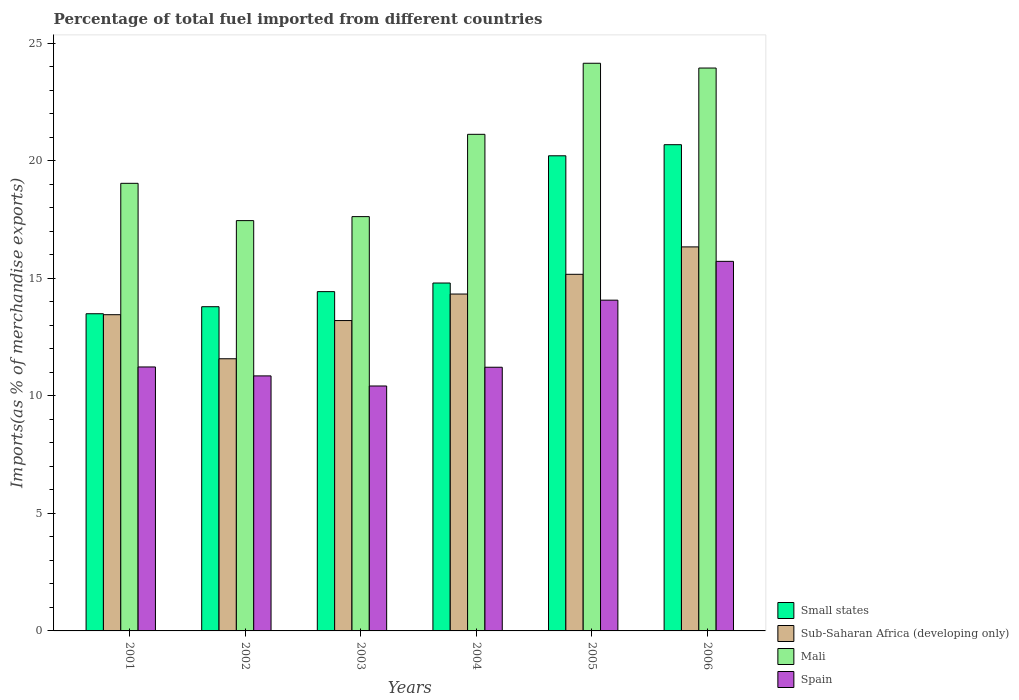How many different coloured bars are there?
Give a very brief answer. 4. How many groups of bars are there?
Keep it short and to the point. 6. Are the number of bars on each tick of the X-axis equal?
Your answer should be compact. Yes. How many bars are there on the 6th tick from the right?
Offer a terse response. 4. What is the label of the 2nd group of bars from the left?
Give a very brief answer. 2002. What is the percentage of imports to different countries in Sub-Saharan Africa (developing only) in 2006?
Your answer should be compact. 16.34. Across all years, what is the maximum percentage of imports to different countries in Mali?
Your response must be concise. 24.16. Across all years, what is the minimum percentage of imports to different countries in Sub-Saharan Africa (developing only)?
Make the answer very short. 11.58. In which year was the percentage of imports to different countries in Spain minimum?
Offer a terse response. 2003. What is the total percentage of imports to different countries in Spain in the graph?
Your response must be concise. 73.53. What is the difference between the percentage of imports to different countries in Mali in 2001 and that in 2004?
Offer a very short reply. -2.09. What is the difference between the percentage of imports to different countries in Sub-Saharan Africa (developing only) in 2003 and the percentage of imports to different countries in Mali in 2002?
Make the answer very short. -4.25. What is the average percentage of imports to different countries in Mali per year?
Provide a succinct answer. 20.56. In the year 2003, what is the difference between the percentage of imports to different countries in Mali and percentage of imports to different countries in Small states?
Make the answer very short. 3.19. What is the ratio of the percentage of imports to different countries in Spain in 2002 to that in 2004?
Make the answer very short. 0.97. Is the difference between the percentage of imports to different countries in Mali in 2002 and 2005 greater than the difference between the percentage of imports to different countries in Small states in 2002 and 2005?
Your response must be concise. No. What is the difference between the highest and the second highest percentage of imports to different countries in Mali?
Offer a very short reply. 0.2. What is the difference between the highest and the lowest percentage of imports to different countries in Spain?
Your response must be concise. 5.3. Is the sum of the percentage of imports to different countries in Sub-Saharan Africa (developing only) in 2001 and 2004 greater than the maximum percentage of imports to different countries in Mali across all years?
Provide a succinct answer. Yes. Is it the case that in every year, the sum of the percentage of imports to different countries in Spain and percentage of imports to different countries in Sub-Saharan Africa (developing only) is greater than the sum of percentage of imports to different countries in Small states and percentage of imports to different countries in Mali?
Keep it short and to the point. No. What does the 3rd bar from the left in 2002 represents?
Offer a terse response. Mali. Is it the case that in every year, the sum of the percentage of imports to different countries in Mali and percentage of imports to different countries in Small states is greater than the percentage of imports to different countries in Sub-Saharan Africa (developing only)?
Provide a succinct answer. Yes. Are all the bars in the graph horizontal?
Keep it short and to the point. No. How many years are there in the graph?
Give a very brief answer. 6. What is the difference between two consecutive major ticks on the Y-axis?
Provide a succinct answer. 5. Are the values on the major ticks of Y-axis written in scientific E-notation?
Provide a succinct answer. No. Does the graph contain any zero values?
Your response must be concise. No. How many legend labels are there?
Your answer should be very brief. 4. How are the legend labels stacked?
Your answer should be compact. Vertical. What is the title of the graph?
Make the answer very short. Percentage of total fuel imported from different countries. Does "Swaziland" appear as one of the legend labels in the graph?
Ensure brevity in your answer.  No. What is the label or title of the Y-axis?
Offer a terse response. Imports(as % of merchandise exports). What is the Imports(as % of merchandise exports) of Small states in 2001?
Keep it short and to the point. 13.5. What is the Imports(as % of merchandise exports) in Sub-Saharan Africa (developing only) in 2001?
Provide a short and direct response. 13.46. What is the Imports(as % of merchandise exports) in Mali in 2001?
Your response must be concise. 19.05. What is the Imports(as % of merchandise exports) of Spain in 2001?
Provide a short and direct response. 11.23. What is the Imports(as % of merchandise exports) of Small states in 2002?
Your answer should be very brief. 13.8. What is the Imports(as % of merchandise exports) of Sub-Saharan Africa (developing only) in 2002?
Keep it short and to the point. 11.58. What is the Imports(as % of merchandise exports) of Mali in 2002?
Offer a terse response. 17.46. What is the Imports(as % of merchandise exports) of Spain in 2002?
Ensure brevity in your answer.  10.85. What is the Imports(as % of merchandise exports) of Small states in 2003?
Your answer should be very brief. 14.44. What is the Imports(as % of merchandise exports) in Sub-Saharan Africa (developing only) in 2003?
Offer a terse response. 13.21. What is the Imports(as % of merchandise exports) in Mali in 2003?
Your response must be concise. 17.63. What is the Imports(as % of merchandise exports) of Spain in 2003?
Your answer should be very brief. 10.42. What is the Imports(as % of merchandise exports) of Small states in 2004?
Make the answer very short. 14.8. What is the Imports(as % of merchandise exports) in Sub-Saharan Africa (developing only) in 2004?
Offer a very short reply. 14.34. What is the Imports(as % of merchandise exports) in Mali in 2004?
Provide a short and direct response. 21.13. What is the Imports(as % of merchandise exports) in Spain in 2004?
Your answer should be compact. 11.22. What is the Imports(as % of merchandise exports) in Small states in 2005?
Offer a terse response. 20.22. What is the Imports(as % of merchandise exports) of Sub-Saharan Africa (developing only) in 2005?
Give a very brief answer. 15.17. What is the Imports(as % of merchandise exports) in Mali in 2005?
Make the answer very short. 24.16. What is the Imports(as % of merchandise exports) of Spain in 2005?
Offer a terse response. 14.07. What is the Imports(as % of merchandise exports) of Small states in 2006?
Your answer should be very brief. 20.69. What is the Imports(as % of merchandise exports) in Sub-Saharan Africa (developing only) in 2006?
Ensure brevity in your answer.  16.34. What is the Imports(as % of merchandise exports) in Mali in 2006?
Give a very brief answer. 23.95. What is the Imports(as % of merchandise exports) in Spain in 2006?
Provide a short and direct response. 15.73. Across all years, what is the maximum Imports(as % of merchandise exports) of Small states?
Ensure brevity in your answer.  20.69. Across all years, what is the maximum Imports(as % of merchandise exports) in Sub-Saharan Africa (developing only)?
Ensure brevity in your answer.  16.34. Across all years, what is the maximum Imports(as % of merchandise exports) of Mali?
Offer a very short reply. 24.16. Across all years, what is the maximum Imports(as % of merchandise exports) in Spain?
Your answer should be compact. 15.73. Across all years, what is the minimum Imports(as % of merchandise exports) of Small states?
Give a very brief answer. 13.5. Across all years, what is the minimum Imports(as % of merchandise exports) of Sub-Saharan Africa (developing only)?
Your response must be concise. 11.58. Across all years, what is the minimum Imports(as % of merchandise exports) in Mali?
Keep it short and to the point. 17.46. Across all years, what is the minimum Imports(as % of merchandise exports) of Spain?
Give a very brief answer. 10.42. What is the total Imports(as % of merchandise exports) in Small states in the graph?
Your response must be concise. 97.44. What is the total Imports(as % of merchandise exports) of Sub-Saharan Africa (developing only) in the graph?
Keep it short and to the point. 84.1. What is the total Imports(as % of merchandise exports) of Mali in the graph?
Keep it short and to the point. 123.38. What is the total Imports(as % of merchandise exports) of Spain in the graph?
Make the answer very short. 73.53. What is the difference between the Imports(as % of merchandise exports) of Small states in 2001 and that in 2002?
Provide a short and direct response. -0.3. What is the difference between the Imports(as % of merchandise exports) in Sub-Saharan Africa (developing only) in 2001 and that in 2002?
Offer a terse response. 1.88. What is the difference between the Imports(as % of merchandise exports) of Mali in 2001 and that in 2002?
Give a very brief answer. 1.59. What is the difference between the Imports(as % of merchandise exports) in Spain in 2001 and that in 2002?
Ensure brevity in your answer.  0.38. What is the difference between the Imports(as % of merchandise exports) in Small states in 2001 and that in 2003?
Offer a very short reply. -0.94. What is the difference between the Imports(as % of merchandise exports) of Sub-Saharan Africa (developing only) in 2001 and that in 2003?
Your answer should be compact. 0.25. What is the difference between the Imports(as % of merchandise exports) in Mali in 2001 and that in 2003?
Make the answer very short. 1.42. What is the difference between the Imports(as % of merchandise exports) in Spain in 2001 and that in 2003?
Provide a short and direct response. 0.81. What is the difference between the Imports(as % of merchandise exports) of Small states in 2001 and that in 2004?
Offer a terse response. -1.31. What is the difference between the Imports(as % of merchandise exports) in Sub-Saharan Africa (developing only) in 2001 and that in 2004?
Offer a terse response. -0.88. What is the difference between the Imports(as % of merchandise exports) of Mali in 2001 and that in 2004?
Offer a very short reply. -2.09. What is the difference between the Imports(as % of merchandise exports) in Spain in 2001 and that in 2004?
Keep it short and to the point. 0.01. What is the difference between the Imports(as % of merchandise exports) of Small states in 2001 and that in 2005?
Make the answer very short. -6.72. What is the difference between the Imports(as % of merchandise exports) in Sub-Saharan Africa (developing only) in 2001 and that in 2005?
Your answer should be compact. -1.72. What is the difference between the Imports(as % of merchandise exports) in Mali in 2001 and that in 2005?
Provide a succinct answer. -5.11. What is the difference between the Imports(as % of merchandise exports) of Spain in 2001 and that in 2005?
Provide a succinct answer. -2.84. What is the difference between the Imports(as % of merchandise exports) of Small states in 2001 and that in 2006?
Your answer should be compact. -7.19. What is the difference between the Imports(as % of merchandise exports) of Sub-Saharan Africa (developing only) in 2001 and that in 2006?
Make the answer very short. -2.89. What is the difference between the Imports(as % of merchandise exports) in Mali in 2001 and that in 2006?
Your response must be concise. -4.91. What is the difference between the Imports(as % of merchandise exports) of Spain in 2001 and that in 2006?
Your response must be concise. -4.49. What is the difference between the Imports(as % of merchandise exports) in Small states in 2002 and that in 2003?
Provide a short and direct response. -0.64. What is the difference between the Imports(as % of merchandise exports) in Sub-Saharan Africa (developing only) in 2002 and that in 2003?
Provide a succinct answer. -1.63. What is the difference between the Imports(as % of merchandise exports) in Mali in 2002 and that in 2003?
Provide a succinct answer. -0.17. What is the difference between the Imports(as % of merchandise exports) of Spain in 2002 and that in 2003?
Give a very brief answer. 0.43. What is the difference between the Imports(as % of merchandise exports) in Small states in 2002 and that in 2004?
Your answer should be very brief. -1.01. What is the difference between the Imports(as % of merchandise exports) of Sub-Saharan Africa (developing only) in 2002 and that in 2004?
Provide a short and direct response. -2.75. What is the difference between the Imports(as % of merchandise exports) in Mali in 2002 and that in 2004?
Provide a short and direct response. -3.67. What is the difference between the Imports(as % of merchandise exports) of Spain in 2002 and that in 2004?
Make the answer very short. -0.37. What is the difference between the Imports(as % of merchandise exports) in Small states in 2002 and that in 2005?
Your answer should be compact. -6.42. What is the difference between the Imports(as % of merchandise exports) in Sub-Saharan Africa (developing only) in 2002 and that in 2005?
Give a very brief answer. -3.59. What is the difference between the Imports(as % of merchandise exports) of Mali in 2002 and that in 2005?
Make the answer very short. -6.7. What is the difference between the Imports(as % of merchandise exports) in Spain in 2002 and that in 2005?
Your response must be concise. -3.22. What is the difference between the Imports(as % of merchandise exports) of Small states in 2002 and that in 2006?
Your answer should be very brief. -6.89. What is the difference between the Imports(as % of merchandise exports) of Sub-Saharan Africa (developing only) in 2002 and that in 2006?
Offer a very short reply. -4.76. What is the difference between the Imports(as % of merchandise exports) of Mali in 2002 and that in 2006?
Your response must be concise. -6.49. What is the difference between the Imports(as % of merchandise exports) of Spain in 2002 and that in 2006?
Offer a very short reply. -4.87. What is the difference between the Imports(as % of merchandise exports) in Small states in 2003 and that in 2004?
Your answer should be very brief. -0.37. What is the difference between the Imports(as % of merchandise exports) of Sub-Saharan Africa (developing only) in 2003 and that in 2004?
Provide a succinct answer. -1.13. What is the difference between the Imports(as % of merchandise exports) in Mali in 2003 and that in 2004?
Offer a very short reply. -3.5. What is the difference between the Imports(as % of merchandise exports) in Spain in 2003 and that in 2004?
Give a very brief answer. -0.8. What is the difference between the Imports(as % of merchandise exports) of Small states in 2003 and that in 2005?
Offer a terse response. -5.78. What is the difference between the Imports(as % of merchandise exports) in Sub-Saharan Africa (developing only) in 2003 and that in 2005?
Provide a short and direct response. -1.97. What is the difference between the Imports(as % of merchandise exports) in Mali in 2003 and that in 2005?
Provide a succinct answer. -6.53. What is the difference between the Imports(as % of merchandise exports) in Spain in 2003 and that in 2005?
Offer a very short reply. -3.65. What is the difference between the Imports(as % of merchandise exports) of Small states in 2003 and that in 2006?
Your response must be concise. -6.25. What is the difference between the Imports(as % of merchandise exports) in Sub-Saharan Africa (developing only) in 2003 and that in 2006?
Keep it short and to the point. -3.13. What is the difference between the Imports(as % of merchandise exports) of Mali in 2003 and that in 2006?
Your response must be concise. -6.32. What is the difference between the Imports(as % of merchandise exports) in Spain in 2003 and that in 2006?
Your answer should be compact. -5.3. What is the difference between the Imports(as % of merchandise exports) in Small states in 2004 and that in 2005?
Offer a very short reply. -5.41. What is the difference between the Imports(as % of merchandise exports) in Sub-Saharan Africa (developing only) in 2004 and that in 2005?
Provide a short and direct response. -0.84. What is the difference between the Imports(as % of merchandise exports) of Mali in 2004 and that in 2005?
Ensure brevity in your answer.  -3.02. What is the difference between the Imports(as % of merchandise exports) in Spain in 2004 and that in 2005?
Provide a short and direct response. -2.85. What is the difference between the Imports(as % of merchandise exports) of Small states in 2004 and that in 2006?
Give a very brief answer. -5.89. What is the difference between the Imports(as % of merchandise exports) of Sub-Saharan Africa (developing only) in 2004 and that in 2006?
Provide a succinct answer. -2.01. What is the difference between the Imports(as % of merchandise exports) in Mali in 2004 and that in 2006?
Provide a short and direct response. -2.82. What is the difference between the Imports(as % of merchandise exports) of Spain in 2004 and that in 2006?
Ensure brevity in your answer.  -4.51. What is the difference between the Imports(as % of merchandise exports) of Small states in 2005 and that in 2006?
Your response must be concise. -0.47. What is the difference between the Imports(as % of merchandise exports) of Sub-Saharan Africa (developing only) in 2005 and that in 2006?
Your answer should be very brief. -1.17. What is the difference between the Imports(as % of merchandise exports) of Mali in 2005 and that in 2006?
Your answer should be compact. 0.2. What is the difference between the Imports(as % of merchandise exports) of Spain in 2005 and that in 2006?
Keep it short and to the point. -1.65. What is the difference between the Imports(as % of merchandise exports) in Small states in 2001 and the Imports(as % of merchandise exports) in Sub-Saharan Africa (developing only) in 2002?
Your response must be concise. 1.92. What is the difference between the Imports(as % of merchandise exports) in Small states in 2001 and the Imports(as % of merchandise exports) in Mali in 2002?
Ensure brevity in your answer.  -3.96. What is the difference between the Imports(as % of merchandise exports) of Small states in 2001 and the Imports(as % of merchandise exports) of Spain in 2002?
Your answer should be compact. 2.64. What is the difference between the Imports(as % of merchandise exports) of Sub-Saharan Africa (developing only) in 2001 and the Imports(as % of merchandise exports) of Mali in 2002?
Ensure brevity in your answer.  -4. What is the difference between the Imports(as % of merchandise exports) in Sub-Saharan Africa (developing only) in 2001 and the Imports(as % of merchandise exports) in Spain in 2002?
Make the answer very short. 2.6. What is the difference between the Imports(as % of merchandise exports) in Mali in 2001 and the Imports(as % of merchandise exports) in Spain in 2002?
Keep it short and to the point. 8.19. What is the difference between the Imports(as % of merchandise exports) in Small states in 2001 and the Imports(as % of merchandise exports) in Sub-Saharan Africa (developing only) in 2003?
Provide a succinct answer. 0.29. What is the difference between the Imports(as % of merchandise exports) of Small states in 2001 and the Imports(as % of merchandise exports) of Mali in 2003?
Provide a succinct answer. -4.13. What is the difference between the Imports(as % of merchandise exports) in Small states in 2001 and the Imports(as % of merchandise exports) in Spain in 2003?
Offer a terse response. 3.07. What is the difference between the Imports(as % of merchandise exports) of Sub-Saharan Africa (developing only) in 2001 and the Imports(as % of merchandise exports) of Mali in 2003?
Ensure brevity in your answer.  -4.17. What is the difference between the Imports(as % of merchandise exports) of Sub-Saharan Africa (developing only) in 2001 and the Imports(as % of merchandise exports) of Spain in 2003?
Give a very brief answer. 3.03. What is the difference between the Imports(as % of merchandise exports) in Mali in 2001 and the Imports(as % of merchandise exports) in Spain in 2003?
Offer a terse response. 8.62. What is the difference between the Imports(as % of merchandise exports) in Small states in 2001 and the Imports(as % of merchandise exports) in Sub-Saharan Africa (developing only) in 2004?
Give a very brief answer. -0.84. What is the difference between the Imports(as % of merchandise exports) of Small states in 2001 and the Imports(as % of merchandise exports) of Mali in 2004?
Your answer should be very brief. -7.64. What is the difference between the Imports(as % of merchandise exports) in Small states in 2001 and the Imports(as % of merchandise exports) in Spain in 2004?
Keep it short and to the point. 2.28. What is the difference between the Imports(as % of merchandise exports) of Sub-Saharan Africa (developing only) in 2001 and the Imports(as % of merchandise exports) of Mali in 2004?
Give a very brief answer. -7.68. What is the difference between the Imports(as % of merchandise exports) of Sub-Saharan Africa (developing only) in 2001 and the Imports(as % of merchandise exports) of Spain in 2004?
Your answer should be compact. 2.24. What is the difference between the Imports(as % of merchandise exports) in Mali in 2001 and the Imports(as % of merchandise exports) in Spain in 2004?
Your answer should be compact. 7.83. What is the difference between the Imports(as % of merchandise exports) of Small states in 2001 and the Imports(as % of merchandise exports) of Sub-Saharan Africa (developing only) in 2005?
Provide a short and direct response. -1.68. What is the difference between the Imports(as % of merchandise exports) of Small states in 2001 and the Imports(as % of merchandise exports) of Mali in 2005?
Make the answer very short. -10.66. What is the difference between the Imports(as % of merchandise exports) in Small states in 2001 and the Imports(as % of merchandise exports) in Spain in 2005?
Offer a very short reply. -0.58. What is the difference between the Imports(as % of merchandise exports) of Sub-Saharan Africa (developing only) in 2001 and the Imports(as % of merchandise exports) of Mali in 2005?
Give a very brief answer. -10.7. What is the difference between the Imports(as % of merchandise exports) in Sub-Saharan Africa (developing only) in 2001 and the Imports(as % of merchandise exports) in Spain in 2005?
Your answer should be very brief. -0.62. What is the difference between the Imports(as % of merchandise exports) of Mali in 2001 and the Imports(as % of merchandise exports) of Spain in 2005?
Your response must be concise. 4.97. What is the difference between the Imports(as % of merchandise exports) of Small states in 2001 and the Imports(as % of merchandise exports) of Sub-Saharan Africa (developing only) in 2006?
Your answer should be very brief. -2.84. What is the difference between the Imports(as % of merchandise exports) of Small states in 2001 and the Imports(as % of merchandise exports) of Mali in 2006?
Give a very brief answer. -10.46. What is the difference between the Imports(as % of merchandise exports) in Small states in 2001 and the Imports(as % of merchandise exports) in Spain in 2006?
Keep it short and to the point. -2.23. What is the difference between the Imports(as % of merchandise exports) in Sub-Saharan Africa (developing only) in 2001 and the Imports(as % of merchandise exports) in Mali in 2006?
Make the answer very short. -10.5. What is the difference between the Imports(as % of merchandise exports) of Sub-Saharan Africa (developing only) in 2001 and the Imports(as % of merchandise exports) of Spain in 2006?
Make the answer very short. -2.27. What is the difference between the Imports(as % of merchandise exports) in Mali in 2001 and the Imports(as % of merchandise exports) in Spain in 2006?
Your answer should be compact. 3.32. What is the difference between the Imports(as % of merchandise exports) in Small states in 2002 and the Imports(as % of merchandise exports) in Sub-Saharan Africa (developing only) in 2003?
Give a very brief answer. 0.59. What is the difference between the Imports(as % of merchandise exports) in Small states in 2002 and the Imports(as % of merchandise exports) in Mali in 2003?
Provide a succinct answer. -3.83. What is the difference between the Imports(as % of merchandise exports) in Small states in 2002 and the Imports(as % of merchandise exports) in Spain in 2003?
Give a very brief answer. 3.37. What is the difference between the Imports(as % of merchandise exports) in Sub-Saharan Africa (developing only) in 2002 and the Imports(as % of merchandise exports) in Mali in 2003?
Your answer should be very brief. -6.05. What is the difference between the Imports(as % of merchandise exports) in Sub-Saharan Africa (developing only) in 2002 and the Imports(as % of merchandise exports) in Spain in 2003?
Your answer should be compact. 1.16. What is the difference between the Imports(as % of merchandise exports) of Mali in 2002 and the Imports(as % of merchandise exports) of Spain in 2003?
Keep it short and to the point. 7.04. What is the difference between the Imports(as % of merchandise exports) of Small states in 2002 and the Imports(as % of merchandise exports) of Sub-Saharan Africa (developing only) in 2004?
Your response must be concise. -0.54. What is the difference between the Imports(as % of merchandise exports) of Small states in 2002 and the Imports(as % of merchandise exports) of Mali in 2004?
Provide a succinct answer. -7.34. What is the difference between the Imports(as % of merchandise exports) in Small states in 2002 and the Imports(as % of merchandise exports) in Spain in 2004?
Your response must be concise. 2.58. What is the difference between the Imports(as % of merchandise exports) of Sub-Saharan Africa (developing only) in 2002 and the Imports(as % of merchandise exports) of Mali in 2004?
Offer a very short reply. -9.55. What is the difference between the Imports(as % of merchandise exports) in Sub-Saharan Africa (developing only) in 2002 and the Imports(as % of merchandise exports) in Spain in 2004?
Keep it short and to the point. 0.36. What is the difference between the Imports(as % of merchandise exports) in Mali in 2002 and the Imports(as % of merchandise exports) in Spain in 2004?
Your response must be concise. 6.24. What is the difference between the Imports(as % of merchandise exports) of Small states in 2002 and the Imports(as % of merchandise exports) of Sub-Saharan Africa (developing only) in 2005?
Your answer should be compact. -1.38. What is the difference between the Imports(as % of merchandise exports) in Small states in 2002 and the Imports(as % of merchandise exports) in Mali in 2005?
Keep it short and to the point. -10.36. What is the difference between the Imports(as % of merchandise exports) in Small states in 2002 and the Imports(as % of merchandise exports) in Spain in 2005?
Offer a terse response. -0.28. What is the difference between the Imports(as % of merchandise exports) in Sub-Saharan Africa (developing only) in 2002 and the Imports(as % of merchandise exports) in Mali in 2005?
Make the answer very short. -12.57. What is the difference between the Imports(as % of merchandise exports) of Sub-Saharan Africa (developing only) in 2002 and the Imports(as % of merchandise exports) of Spain in 2005?
Your answer should be very brief. -2.49. What is the difference between the Imports(as % of merchandise exports) in Mali in 2002 and the Imports(as % of merchandise exports) in Spain in 2005?
Keep it short and to the point. 3.39. What is the difference between the Imports(as % of merchandise exports) in Small states in 2002 and the Imports(as % of merchandise exports) in Sub-Saharan Africa (developing only) in 2006?
Offer a terse response. -2.55. What is the difference between the Imports(as % of merchandise exports) in Small states in 2002 and the Imports(as % of merchandise exports) in Mali in 2006?
Offer a very short reply. -10.16. What is the difference between the Imports(as % of merchandise exports) in Small states in 2002 and the Imports(as % of merchandise exports) in Spain in 2006?
Provide a short and direct response. -1.93. What is the difference between the Imports(as % of merchandise exports) in Sub-Saharan Africa (developing only) in 2002 and the Imports(as % of merchandise exports) in Mali in 2006?
Keep it short and to the point. -12.37. What is the difference between the Imports(as % of merchandise exports) in Sub-Saharan Africa (developing only) in 2002 and the Imports(as % of merchandise exports) in Spain in 2006?
Offer a very short reply. -4.14. What is the difference between the Imports(as % of merchandise exports) in Mali in 2002 and the Imports(as % of merchandise exports) in Spain in 2006?
Give a very brief answer. 1.73. What is the difference between the Imports(as % of merchandise exports) in Small states in 2003 and the Imports(as % of merchandise exports) in Sub-Saharan Africa (developing only) in 2004?
Offer a very short reply. 0.1. What is the difference between the Imports(as % of merchandise exports) in Small states in 2003 and the Imports(as % of merchandise exports) in Mali in 2004?
Keep it short and to the point. -6.69. What is the difference between the Imports(as % of merchandise exports) of Small states in 2003 and the Imports(as % of merchandise exports) of Spain in 2004?
Your answer should be very brief. 3.22. What is the difference between the Imports(as % of merchandise exports) in Sub-Saharan Africa (developing only) in 2003 and the Imports(as % of merchandise exports) in Mali in 2004?
Offer a very short reply. -7.92. What is the difference between the Imports(as % of merchandise exports) of Sub-Saharan Africa (developing only) in 2003 and the Imports(as % of merchandise exports) of Spain in 2004?
Your answer should be very brief. 1.99. What is the difference between the Imports(as % of merchandise exports) of Mali in 2003 and the Imports(as % of merchandise exports) of Spain in 2004?
Offer a very short reply. 6.41. What is the difference between the Imports(as % of merchandise exports) of Small states in 2003 and the Imports(as % of merchandise exports) of Sub-Saharan Africa (developing only) in 2005?
Provide a succinct answer. -0.74. What is the difference between the Imports(as % of merchandise exports) in Small states in 2003 and the Imports(as % of merchandise exports) in Mali in 2005?
Your answer should be very brief. -9.72. What is the difference between the Imports(as % of merchandise exports) of Small states in 2003 and the Imports(as % of merchandise exports) of Spain in 2005?
Offer a very short reply. 0.36. What is the difference between the Imports(as % of merchandise exports) in Sub-Saharan Africa (developing only) in 2003 and the Imports(as % of merchandise exports) in Mali in 2005?
Provide a succinct answer. -10.95. What is the difference between the Imports(as % of merchandise exports) in Sub-Saharan Africa (developing only) in 2003 and the Imports(as % of merchandise exports) in Spain in 2005?
Provide a short and direct response. -0.87. What is the difference between the Imports(as % of merchandise exports) in Mali in 2003 and the Imports(as % of merchandise exports) in Spain in 2005?
Your answer should be very brief. 3.56. What is the difference between the Imports(as % of merchandise exports) in Small states in 2003 and the Imports(as % of merchandise exports) in Sub-Saharan Africa (developing only) in 2006?
Your response must be concise. -1.9. What is the difference between the Imports(as % of merchandise exports) in Small states in 2003 and the Imports(as % of merchandise exports) in Mali in 2006?
Offer a terse response. -9.52. What is the difference between the Imports(as % of merchandise exports) in Small states in 2003 and the Imports(as % of merchandise exports) in Spain in 2006?
Your answer should be compact. -1.29. What is the difference between the Imports(as % of merchandise exports) in Sub-Saharan Africa (developing only) in 2003 and the Imports(as % of merchandise exports) in Mali in 2006?
Your answer should be very brief. -10.75. What is the difference between the Imports(as % of merchandise exports) in Sub-Saharan Africa (developing only) in 2003 and the Imports(as % of merchandise exports) in Spain in 2006?
Provide a short and direct response. -2.52. What is the difference between the Imports(as % of merchandise exports) in Mali in 2003 and the Imports(as % of merchandise exports) in Spain in 2006?
Provide a succinct answer. 1.9. What is the difference between the Imports(as % of merchandise exports) of Small states in 2004 and the Imports(as % of merchandise exports) of Sub-Saharan Africa (developing only) in 2005?
Provide a short and direct response. -0.37. What is the difference between the Imports(as % of merchandise exports) of Small states in 2004 and the Imports(as % of merchandise exports) of Mali in 2005?
Give a very brief answer. -9.35. What is the difference between the Imports(as % of merchandise exports) in Small states in 2004 and the Imports(as % of merchandise exports) in Spain in 2005?
Your response must be concise. 0.73. What is the difference between the Imports(as % of merchandise exports) in Sub-Saharan Africa (developing only) in 2004 and the Imports(as % of merchandise exports) in Mali in 2005?
Provide a short and direct response. -9.82. What is the difference between the Imports(as % of merchandise exports) in Sub-Saharan Africa (developing only) in 2004 and the Imports(as % of merchandise exports) in Spain in 2005?
Give a very brief answer. 0.26. What is the difference between the Imports(as % of merchandise exports) in Mali in 2004 and the Imports(as % of merchandise exports) in Spain in 2005?
Keep it short and to the point. 7.06. What is the difference between the Imports(as % of merchandise exports) of Small states in 2004 and the Imports(as % of merchandise exports) of Sub-Saharan Africa (developing only) in 2006?
Your answer should be compact. -1.54. What is the difference between the Imports(as % of merchandise exports) in Small states in 2004 and the Imports(as % of merchandise exports) in Mali in 2006?
Give a very brief answer. -9.15. What is the difference between the Imports(as % of merchandise exports) in Small states in 2004 and the Imports(as % of merchandise exports) in Spain in 2006?
Your response must be concise. -0.92. What is the difference between the Imports(as % of merchandise exports) of Sub-Saharan Africa (developing only) in 2004 and the Imports(as % of merchandise exports) of Mali in 2006?
Keep it short and to the point. -9.62. What is the difference between the Imports(as % of merchandise exports) in Sub-Saharan Africa (developing only) in 2004 and the Imports(as % of merchandise exports) in Spain in 2006?
Give a very brief answer. -1.39. What is the difference between the Imports(as % of merchandise exports) in Mali in 2004 and the Imports(as % of merchandise exports) in Spain in 2006?
Keep it short and to the point. 5.41. What is the difference between the Imports(as % of merchandise exports) in Small states in 2005 and the Imports(as % of merchandise exports) in Sub-Saharan Africa (developing only) in 2006?
Your answer should be very brief. 3.88. What is the difference between the Imports(as % of merchandise exports) in Small states in 2005 and the Imports(as % of merchandise exports) in Mali in 2006?
Offer a very short reply. -3.73. What is the difference between the Imports(as % of merchandise exports) in Small states in 2005 and the Imports(as % of merchandise exports) in Spain in 2006?
Keep it short and to the point. 4.49. What is the difference between the Imports(as % of merchandise exports) of Sub-Saharan Africa (developing only) in 2005 and the Imports(as % of merchandise exports) of Mali in 2006?
Offer a very short reply. -8.78. What is the difference between the Imports(as % of merchandise exports) in Sub-Saharan Africa (developing only) in 2005 and the Imports(as % of merchandise exports) in Spain in 2006?
Make the answer very short. -0.55. What is the difference between the Imports(as % of merchandise exports) in Mali in 2005 and the Imports(as % of merchandise exports) in Spain in 2006?
Ensure brevity in your answer.  8.43. What is the average Imports(as % of merchandise exports) in Small states per year?
Offer a terse response. 16.24. What is the average Imports(as % of merchandise exports) in Sub-Saharan Africa (developing only) per year?
Keep it short and to the point. 14.02. What is the average Imports(as % of merchandise exports) of Mali per year?
Give a very brief answer. 20.56. What is the average Imports(as % of merchandise exports) in Spain per year?
Offer a very short reply. 12.25. In the year 2001, what is the difference between the Imports(as % of merchandise exports) of Small states and Imports(as % of merchandise exports) of Sub-Saharan Africa (developing only)?
Provide a succinct answer. 0.04. In the year 2001, what is the difference between the Imports(as % of merchandise exports) in Small states and Imports(as % of merchandise exports) in Mali?
Keep it short and to the point. -5.55. In the year 2001, what is the difference between the Imports(as % of merchandise exports) in Small states and Imports(as % of merchandise exports) in Spain?
Provide a short and direct response. 2.26. In the year 2001, what is the difference between the Imports(as % of merchandise exports) in Sub-Saharan Africa (developing only) and Imports(as % of merchandise exports) in Mali?
Your answer should be very brief. -5.59. In the year 2001, what is the difference between the Imports(as % of merchandise exports) of Sub-Saharan Africa (developing only) and Imports(as % of merchandise exports) of Spain?
Give a very brief answer. 2.22. In the year 2001, what is the difference between the Imports(as % of merchandise exports) in Mali and Imports(as % of merchandise exports) in Spain?
Your answer should be compact. 7.81. In the year 2002, what is the difference between the Imports(as % of merchandise exports) of Small states and Imports(as % of merchandise exports) of Sub-Saharan Africa (developing only)?
Offer a very short reply. 2.21. In the year 2002, what is the difference between the Imports(as % of merchandise exports) of Small states and Imports(as % of merchandise exports) of Mali?
Ensure brevity in your answer.  -3.66. In the year 2002, what is the difference between the Imports(as % of merchandise exports) in Small states and Imports(as % of merchandise exports) in Spain?
Your answer should be compact. 2.94. In the year 2002, what is the difference between the Imports(as % of merchandise exports) in Sub-Saharan Africa (developing only) and Imports(as % of merchandise exports) in Mali?
Your answer should be very brief. -5.88. In the year 2002, what is the difference between the Imports(as % of merchandise exports) in Sub-Saharan Africa (developing only) and Imports(as % of merchandise exports) in Spain?
Keep it short and to the point. 0.73. In the year 2002, what is the difference between the Imports(as % of merchandise exports) in Mali and Imports(as % of merchandise exports) in Spain?
Your answer should be compact. 6.61. In the year 2003, what is the difference between the Imports(as % of merchandise exports) of Small states and Imports(as % of merchandise exports) of Sub-Saharan Africa (developing only)?
Provide a short and direct response. 1.23. In the year 2003, what is the difference between the Imports(as % of merchandise exports) in Small states and Imports(as % of merchandise exports) in Mali?
Provide a succinct answer. -3.19. In the year 2003, what is the difference between the Imports(as % of merchandise exports) of Small states and Imports(as % of merchandise exports) of Spain?
Offer a very short reply. 4.01. In the year 2003, what is the difference between the Imports(as % of merchandise exports) in Sub-Saharan Africa (developing only) and Imports(as % of merchandise exports) in Mali?
Your answer should be compact. -4.42. In the year 2003, what is the difference between the Imports(as % of merchandise exports) of Sub-Saharan Africa (developing only) and Imports(as % of merchandise exports) of Spain?
Offer a very short reply. 2.78. In the year 2003, what is the difference between the Imports(as % of merchandise exports) in Mali and Imports(as % of merchandise exports) in Spain?
Make the answer very short. 7.21. In the year 2004, what is the difference between the Imports(as % of merchandise exports) in Small states and Imports(as % of merchandise exports) in Sub-Saharan Africa (developing only)?
Provide a succinct answer. 0.47. In the year 2004, what is the difference between the Imports(as % of merchandise exports) of Small states and Imports(as % of merchandise exports) of Mali?
Your answer should be compact. -6.33. In the year 2004, what is the difference between the Imports(as % of merchandise exports) in Small states and Imports(as % of merchandise exports) in Spain?
Keep it short and to the point. 3.58. In the year 2004, what is the difference between the Imports(as % of merchandise exports) in Sub-Saharan Africa (developing only) and Imports(as % of merchandise exports) in Mali?
Your answer should be very brief. -6.8. In the year 2004, what is the difference between the Imports(as % of merchandise exports) in Sub-Saharan Africa (developing only) and Imports(as % of merchandise exports) in Spain?
Ensure brevity in your answer.  3.12. In the year 2004, what is the difference between the Imports(as % of merchandise exports) in Mali and Imports(as % of merchandise exports) in Spain?
Provide a short and direct response. 9.91. In the year 2005, what is the difference between the Imports(as % of merchandise exports) of Small states and Imports(as % of merchandise exports) of Sub-Saharan Africa (developing only)?
Your response must be concise. 5.04. In the year 2005, what is the difference between the Imports(as % of merchandise exports) of Small states and Imports(as % of merchandise exports) of Mali?
Provide a short and direct response. -3.94. In the year 2005, what is the difference between the Imports(as % of merchandise exports) of Small states and Imports(as % of merchandise exports) of Spain?
Your answer should be compact. 6.14. In the year 2005, what is the difference between the Imports(as % of merchandise exports) in Sub-Saharan Africa (developing only) and Imports(as % of merchandise exports) in Mali?
Provide a short and direct response. -8.98. In the year 2005, what is the difference between the Imports(as % of merchandise exports) of Sub-Saharan Africa (developing only) and Imports(as % of merchandise exports) of Spain?
Your answer should be compact. 1.1. In the year 2005, what is the difference between the Imports(as % of merchandise exports) in Mali and Imports(as % of merchandise exports) in Spain?
Offer a terse response. 10.08. In the year 2006, what is the difference between the Imports(as % of merchandise exports) of Small states and Imports(as % of merchandise exports) of Sub-Saharan Africa (developing only)?
Provide a succinct answer. 4.35. In the year 2006, what is the difference between the Imports(as % of merchandise exports) of Small states and Imports(as % of merchandise exports) of Mali?
Offer a terse response. -3.26. In the year 2006, what is the difference between the Imports(as % of merchandise exports) in Small states and Imports(as % of merchandise exports) in Spain?
Provide a succinct answer. 4.96. In the year 2006, what is the difference between the Imports(as % of merchandise exports) in Sub-Saharan Africa (developing only) and Imports(as % of merchandise exports) in Mali?
Offer a very short reply. -7.61. In the year 2006, what is the difference between the Imports(as % of merchandise exports) of Sub-Saharan Africa (developing only) and Imports(as % of merchandise exports) of Spain?
Ensure brevity in your answer.  0.62. In the year 2006, what is the difference between the Imports(as % of merchandise exports) of Mali and Imports(as % of merchandise exports) of Spain?
Give a very brief answer. 8.23. What is the ratio of the Imports(as % of merchandise exports) of Small states in 2001 to that in 2002?
Your answer should be very brief. 0.98. What is the ratio of the Imports(as % of merchandise exports) in Sub-Saharan Africa (developing only) in 2001 to that in 2002?
Provide a succinct answer. 1.16. What is the ratio of the Imports(as % of merchandise exports) in Spain in 2001 to that in 2002?
Your answer should be very brief. 1.04. What is the ratio of the Imports(as % of merchandise exports) in Small states in 2001 to that in 2003?
Offer a very short reply. 0.93. What is the ratio of the Imports(as % of merchandise exports) in Sub-Saharan Africa (developing only) in 2001 to that in 2003?
Provide a short and direct response. 1.02. What is the ratio of the Imports(as % of merchandise exports) of Mali in 2001 to that in 2003?
Give a very brief answer. 1.08. What is the ratio of the Imports(as % of merchandise exports) in Spain in 2001 to that in 2003?
Provide a short and direct response. 1.08. What is the ratio of the Imports(as % of merchandise exports) in Small states in 2001 to that in 2004?
Offer a terse response. 0.91. What is the ratio of the Imports(as % of merchandise exports) in Sub-Saharan Africa (developing only) in 2001 to that in 2004?
Ensure brevity in your answer.  0.94. What is the ratio of the Imports(as % of merchandise exports) of Mali in 2001 to that in 2004?
Give a very brief answer. 0.9. What is the ratio of the Imports(as % of merchandise exports) in Spain in 2001 to that in 2004?
Provide a succinct answer. 1. What is the ratio of the Imports(as % of merchandise exports) of Small states in 2001 to that in 2005?
Give a very brief answer. 0.67. What is the ratio of the Imports(as % of merchandise exports) of Sub-Saharan Africa (developing only) in 2001 to that in 2005?
Offer a very short reply. 0.89. What is the ratio of the Imports(as % of merchandise exports) of Mali in 2001 to that in 2005?
Make the answer very short. 0.79. What is the ratio of the Imports(as % of merchandise exports) in Spain in 2001 to that in 2005?
Your response must be concise. 0.8. What is the ratio of the Imports(as % of merchandise exports) of Small states in 2001 to that in 2006?
Give a very brief answer. 0.65. What is the ratio of the Imports(as % of merchandise exports) of Sub-Saharan Africa (developing only) in 2001 to that in 2006?
Offer a terse response. 0.82. What is the ratio of the Imports(as % of merchandise exports) of Mali in 2001 to that in 2006?
Provide a succinct answer. 0.8. What is the ratio of the Imports(as % of merchandise exports) of Small states in 2002 to that in 2003?
Provide a succinct answer. 0.96. What is the ratio of the Imports(as % of merchandise exports) in Sub-Saharan Africa (developing only) in 2002 to that in 2003?
Your answer should be compact. 0.88. What is the ratio of the Imports(as % of merchandise exports) in Mali in 2002 to that in 2003?
Offer a terse response. 0.99. What is the ratio of the Imports(as % of merchandise exports) in Spain in 2002 to that in 2003?
Provide a succinct answer. 1.04. What is the ratio of the Imports(as % of merchandise exports) of Small states in 2002 to that in 2004?
Your response must be concise. 0.93. What is the ratio of the Imports(as % of merchandise exports) in Sub-Saharan Africa (developing only) in 2002 to that in 2004?
Ensure brevity in your answer.  0.81. What is the ratio of the Imports(as % of merchandise exports) in Mali in 2002 to that in 2004?
Give a very brief answer. 0.83. What is the ratio of the Imports(as % of merchandise exports) of Spain in 2002 to that in 2004?
Offer a very short reply. 0.97. What is the ratio of the Imports(as % of merchandise exports) in Small states in 2002 to that in 2005?
Provide a short and direct response. 0.68. What is the ratio of the Imports(as % of merchandise exports) in Sub-Saharan Africa (developing only) in 2002 to that in 2005?
Your response must be concise. 0.76. What is the ratio of the Imports(as % of merchandise exports) in Mali in 2002 to that in 2005?
Make the answer very short. 0.72. What is the ratio of the Imports(as % of merchandise exports) in Spain in 2002 to that in 2005?
Offer a very short reply. 0.77. What is the ratio of the Imports(as % of merchandise exports) of Small states in 2002 to that in 2006?
Ensure brevity in your answer.  0.67. What is the ratio of the Imports(as % of merchandise exports) of Sub-Saharan Africa (developing only) in 2002 to that in 2006?
Your answer should be very brief. 0.71. What is the ratio of the Imports(as % of merchandise exports) of Mali in 2002 to that in 2006?
Offer a very short reply. 0.73. What is the ratio of the Imports(as % of merchandise exports) in Spain in 2002 to that in 2006?
Keep it short and to the point. 0.69. What is the ratio of the Imports(as % of merchandise exports) in Small states in 2003 to that in 2004?
Keep it short and to the point. 0.98. What is the ratio of the Imports(as % of merchandise exports) of Sub-Saharan Africa (developing only) in 2003 to that in 2004?
Your answer should be compact. 0.92. What is the ratio of the Imports(as % of merchandise exports) in Mali in 2003 to that in 2004?
Ensure brevity in your answer.  0.83. What is the ratio of the Imports(as % of merchandise exports) in Spain in 2003 to that in 2004?
Provide a short and direct response. 0.93. What is the ratio of the Imports(as % of merchandise exports) of Small states in 2003 to that in 2005?
Your answer should be very brief. 0.71. What is the ratio of the Imports(as % of merchandise exports) of Sub-Saharan Africa (developing only) in 2003 to that in 2005?
Make the answer very short. 0.87. What is the ratio of the Imports(as % of merchandise exports) in Mali in 2003 to that in 2005?
Your answer should be very brief. 0.73. What is the ratio of the Imports(as % of merchandise exports) in Spain in 2003 to that in 2005?
Your response must be concise. 0.74. What is the ratio of the Imports(as % of merchandise exports) in Small states in 2003 to that in 2006?
Your response must be concise. 0.7. What is the ratio of the Imports(as % of merchandise exports) in Sub-Saharan Africa (developing only) in 2003 to that in 2006?
Provide a succinct answer. 0.81. What is the ratio of the Imports(as % of merchandise exports) of Mali in 2003 to that in 2006?
Give a very brief answer. 0.74. What is the ratio of the Imports(as % of merchandise exports) of Spain in 2003 to that in 2006?
Your response must be concise. 0.66. What is the ratio of the Imports(as % of merchandise exports) in Small states in 2004 to that in 2005?
Make the answer very short. 0.73. What is the ratio of the Imports(as % of merchandise exports) of Sub-Saharan Africa (developing only) in 2004 to that in 2005?
Provide a succinct answer. 0.94. What is the ratio of the Imports(as % of merchandise exports) in Mali in 2004 to that in 2005?
Offer a terse response. 0.87. What is the ratio of the Imports(as % of merchandise exports) of Spain in 2004 to that in 2005?
Your response must be concise. 0.8. What is the ratio of the Imports(as % of merchandise exports) in Small states in 2004 to that in 2006?
Offer a very short reply. 0.72. What is the ratio of the Imports(as % of merchandise exports) of Sub-Saharan Africa (developing only) in 2004 to that in 2006?
Keep it short and to the point. 0.88. What is the ratio of the Imports(as % of merchandise exports) in Mali in 2004 to that in 2006?
Offer a terse response. 0.88. What is the ratio of the Imports(as % of merchandise exports) of Spain in 2004 to that in 2006?
Ensure brevity in your answer.  0.71. What is the ratio of the Imports(as % of merchandise exports) of Small states in 2005 to that in 2006?
Offer a terse response. 0.98. What is the ratio of the Imports(as % of merchandise exports) of Sub-Saharan Africa (developing only) in 2005 to that in 2006?
Offer a terse response. 0.93. What is the ratio of the Imports(as % of merchandise exports) of Mali in 2005 to that in 2006?
Provide a succinct answer. 1.01. What is the ratio of the Imports(as % of merchandise exports) in Spain in 2005 to that in 2006?
Provide a short and direct response. 0.9. What is the difference between the highest and the second highest Imports(as % of merchandise exports) in Small states?
Your answer should be very brief. 0.47. What is the difference between the highest and the second highest Imports(as % of merchandise exports) in Sub-Saharan Africa (developing only)?
Ensure brevity in your answer.  1.17. What is the difference between the highest and the second highest Imports(as % of merchandise exports) of Mali?
Offer a terse response. 0.2. What is the difference between the highest and the second highest Imports(as % of merchandise exports) in Spain?
Provide a succinct answer. 1.65. What is the difference between the highest and the lowest Imports(as % of merchandise exports) of Small states?
Keep it short and to the point. 7.19. What is the difference between the highest and the lowest Imports(as % of merchandise exports) in Sub-Saharan Africa (developing only)?
Your answer should be very brief. 4.76. What is the difference between the highest and the lowest Imports(as % of merchandise exports) of Mali?
Provide a short and direct response. 6.7. What is the difference between the highest and the lowest Imports(as % of merchandise exports) in Spain?
Your answer should be very brief. 5.3. 